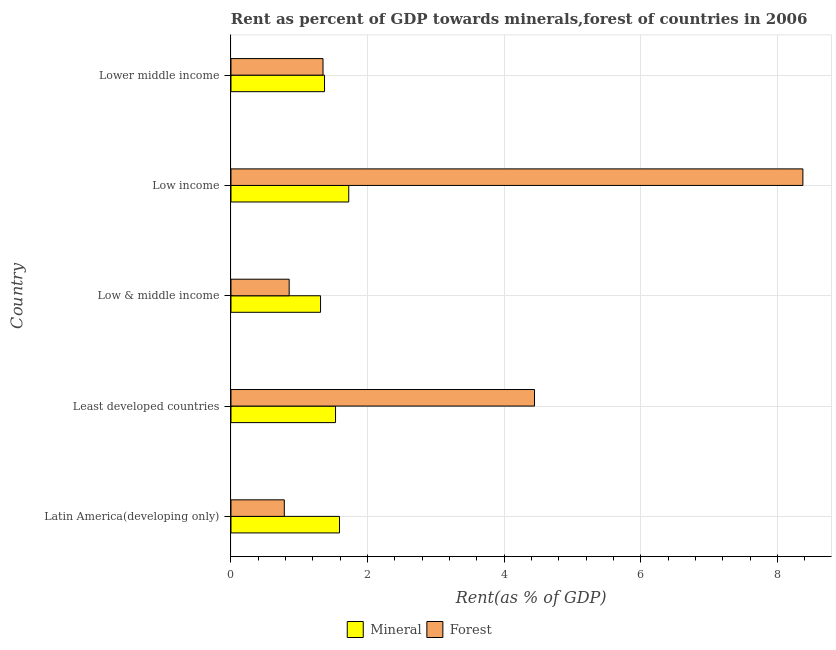Are the number of bars per tick equal to the number of legend labels?
Give a very brief answer. Yes. How many bars are there on the 5th tick from the top?
Offer a terse response. 2. What is the label of the 3rd group of bars from the top?
Give a very brief answer. Low & middle income. What is the mineral rent in Low & middle income?
Your response must be concise. 1.31. Across all countries, what is the maximum forest rent?
Make the answer very short. 8.37. Across all countries, what is the minimum mineral rent?
Your answer should be very brief. 1.31. What is the total forest rent in the graph?
Your answer should be compact. 15.8. What is the difference between the mineral rent in Low income and that in Lower middle income?
Your answer should be compact. 0.35. What is the difference between the mineral rent in Latin America(developing only) and the forest rent in Low income?
Ensure brevity in your answer.  -6.78. What is the average mineral rent per country?
Keep it short and to the point. 1.5. What is the difference between the forest rent and mineral rent in Lower middle income?
Make the answer very short. -0.02. What is the ratio of the mineral rent in Least developed countries to that in Low & middle income?
Give a very brief answer. 1.17. What is the difference between the highest and the second highest mineral rent?
Keep it short and to the point. 0.14. What is the difference between the highest and the lowest mineral rent?
Your answer should be very brief. 0.41. What does the 1st bar from the top in Least developed countries represents?
Provide a succinct answer. Forest. What does the 2nd bar from the bottom in Low income represents?
Your answer should be compact. Forest. How many bars are there?
Make the answer very short. 10. Does the graph contain any zero values?
Give a very brief answer. No. How many legend labels are there?
Offer a terse response. 2. What is the title of the graph?
Provide a short and direct response. Rent as percent of GDP towards minerals,forest of countries in 2006. Does "2012 US$" appear as one of the legend labels in the graph?
Make the answer very short. No. What is the label or title of the X-axis?
Offer a terse response. Rent(as % of GDP). What is the label or title of the Y-axis?
Provide a short and direct response. Country. What is the Rent(as % of GDP) of Mineral in Latin America(developing only)?
Keep it short and to the point. 1.59. What is the Rent(as % of GDP) of Forest in Latin America(developing only)?
Make the answer very short. 0.78. What is the Rent(as % of GDP) in Mineral in Least developed countries?
Your answer should be compact. 1.53. What is the Rent(as % of GDP) in Forest in Least developed countries?
Offer a very short reply. 4.44. What is the Rent(as % of GDP) of Mineral in Low & middle income?
Your answer should be compact. 1.31. What is the Rent(as % of GDP) in Forest in Low & middle income?
Offer a very short reply. 0.85. What is the Rent(as % of GDP) in Mineral in Low income?
Give a very brief answer. 1.72. What is the Rent(as % of GDP) in Forest in Low income?
Offer a terse response. 8.37. What is the Rent(as % of GDP) of Mineral in Lower middle income?
Your response must be concise. 1.37. What is the Rent(as % of GDP) in Forest in Lower middle income?
Your answer should be very brief. 1.35. Across all countries, what is the maximum Rent(as % of GDP) of Mineral?
Your response must be concise. 1.72. Across all countries, what is the maximum Rent(as % of GDP) in Forest?
Provide a short and direct response. 8.37. Across all countries, what is the minimum Rent(as % of GDP) in Mineral?
Your answer should be very brief. 1.31. Across all countries, what is the minimum Rent(as % of GDP) in Forest?
Your answer should be very brief. 0.78. What is the total Rent(as % of GDP) of Mineral in the graph?
Make the answer very short. 7.53. What is the total Rent(as % of GDP) of Forest in the graph?
Provide a short and direct response. 15.8. What is the difference between the Rent(as % of GDP) in Mineral in Latin America(developing only) and that in Least developed countries?
Keep it short and to the point. 0.06. What is the difference between the Rent(as % of GDP) in Forest in Latin America(developing only) and that in Least developed countries?
Offer a terse response. -3.66. What is the difference between the Rent(as % of GDP) in Mineral in Latin America(developing only) and that in Low & middle income?
Offer a terse response. 0.28. What is the difference between the Rent(as % of GDP) in Forest in Latin America(developing only) and that in Low & middle income?
Your answer should be compact. -0.07. What is the difference between the Rent(as % of GDP) in Mineral in Latin America(developing only) and that in Low income?
Ensure brevity in your answer.  -0.14. What is the difference between the Rent(as % of GDP) of Forest in Latin America(developing only) and that in Low income?
Ensure brevity in your answer.  -7.59. What is the difference between the Rent(as % of GDP) in Mineral in Latin America(developing only) and that in Lower middle income?
Your answer should be compact. 0.22. What is the difference between the Rent(as % of GDP) of Forest in Latin America(developing only) and that in Lower middle income?
Provide a short and direct response. -0.57. What is the difference between the Rent(as % of GDP) of Mineral in Least developed countries and that in Low & middle income?
Give a very brief answer. 0.22. What is the difference between the Rent(as % of GDP) in Forest in Least developed countries and that in Low & middle income?
Offer a terse response. 3.59. What is the difference between the Rent(as % of GDP) in Mineral in Least developed countries and that in Low income?
Your answer should be very brief. -0.19. What is the difference between the Rent(as % of GDP) in Forest in Least developed countries and that in Low income?
Your answer should be compact. -3.93. What is the difference between the Rent(as % of GDP) of Mineral in Least developed countries and that in Lower middle income?
Ensure brevity in your answer.  0.16. What is the difference between the Rent(as % of GDP) in Forest in Least developed countries and that in Lower middle income?
Ensure brevity in your answer.  3.1. What is the difference between the Rent(as % of GDP) in Mineral in Low & middle income and that in Low income?
Your answer should be compact. -0.41. What is the difference between the Rent(as % of GDP) in Forest in Low & middle income and that in Low income?
Your answer should be compact. -7.52. What is the difference between the Rent(as % of GDP) of Mineral in Low & middle income and that in Lower middle income?
Give a very brief answer. -0.06. What is the difference between the Rent(as % of GDP) of Forest in Low & middle income and that in Lower middle income?
Offer a terse response. -0.5. What is the difference between the Rent(as % of GDP) of Mineral in Low income and that in Lower middle income?
Offer a terse response. 0.35. What is the difference between the Rent(as % of GDP) in Forest in Low income and that in Lower middle income?
Offer a terse response. 7.03. What is the difference between the Rent(as % of GDP) in Mineral in Latin America(developing only) and the Rent(as % of GDP) in Forest in Least developed countries?
Provide a succinct answer. -2.86. What is the difference between the Rent(as % of GDP) in Mineral in Latin America(developing only) and the Rent(as % of GDP) in Forest in Low & middle income?
Provide a short and direct response. 0.74. What is the difference between the Rent(as % of GDP) in Mineral in Latin America(developing only) and the Rent(as % of GDP) in Forest in Low income?
Your answer should be compact. -6.78. What is the difference between the Rent(as % of GDP) in Mineral in Latin America(developing only) and the Rent(as % of GDP) in Forest in Lower middle income?
Your response must be concise. 0.24. What is the difference between the Rent(as % of GDP) of Mineral in Least developed countries and the Rent(as % of GDP) of Forest in Low & middle income?
Provide a succinct answer. 0.68. What is the difference between the Rent(as % of GDP) of Mineral in Least developed countries and the Rent(as % of GDP) of Forest in Low income?
Offer a very short reply. -6.84. What is the difference between the Rent(as % of GDP) of Mineral in Least developed countries and the Rent(as % of GDP) of Forest in Lower middle income?
Give a very brief answer. 0.18. What is the difference between the Rent(as % of GDP) of Mineral in Low & middle income and the Rent(as % of GDP) of Forest in Low income?
Provide a short and direct response. -7.06. What is the difference between the Rent(as % of GDP) in Mineral in Low & middle income and the Rent(as % of GDP) in Forest in Lower middle income?
Offer a very short reply. -0.04. What is the difference between the Rent(as % of GDP) of Mineral in Low income and the Rent(as % of GDP) of Forest in Lower middle income?
Offer a terse response. 0.38. What is the average Rent(as % of GDP) in Mineral per country?
Offer a terse response. 1.51. What is the average Rent(as % of GDP) of Forest per country?
Offer a very short reply. 3.16. What is the difference between the Rent(as % of GDP) of Mineral and Rent(as % of GDP) of Forest in Latin America(developing only)?
Provide a succinct answer. 0.81. What is the difference between the Rent(as % of GDP) in Mineral and Rent(as % of GDP) in Forest in Least developed countries?
Your answer should be compact. -2.91. What is the difference between the Rent(as % of GDP) in Mineral and Rent(as % of GDP) in Forest in Low & middle income?
Provide a short and direct response. 0.46. What is the difference between the Rent(as % of GDP) of Mineral and Rent(as % of GDP) of Forest in Low income?
Ensure brevity in your answer.  -6.65. What is the difference between the Rent(as % of GDP) of Mineral and Rent(as % of GDP) of Forest in Lower middle income?
Ensure brevity in your answer.  0.02. What is the ratio of the Rent(as % of GDP) in Mineral in Latin America(developing only) to that in Least developed countries?
Provide a succinct answer. 1.04. What is the ratio of the Rent(as % of GDP) in Forest in Latin America(developing only) to that in Least developed countries?
Ensure brevity in your answer.  0.18. What is the ratio of the Rent(as % of GDP) of Mineral in Latin America(developing only) to that in Low & middle income?
Ensure brevity in your answer.  1.21. What is the ratio of the Rent(as % of GDP) of Forest in Latin America(developing only) to that in Low & middle income?
Ensure brevity in your answer.  0.92. What is the ratio of the Rent(as % of GDP) in Mineral in Latin America(developing only) to that in Low income?
Keep it short and to the point. 0.92. What is the ratio of the Rent(as % of GDP) in Forest in Latin America(developing only) to that in Low income?
Your answer should be compact. 0.09. What is the ratio of the Rent(as % of GDP) in Mineral in Latin America(developing only) to that in Lower middle income?
Your response must be concise. 1.16. What is the ratio of the Rent(as % of GDP) of Forest in Latin America(developing only) to that in Lower middle income?
Give a very brief answer. 0.58. What is the ratio of the Rent(as % of GDP) of Mineral in Least developed countries to that in Low & middle income?
Keep it short and to the point. 1.17. What is the ratio of the Rent(as % of GDP) of Forest in Least developed countries to that in Low & middle income?
Keep it short and to the point. 5.22. What is the ratio of the Rent(as % of GDP) of Mineral in Least developed countries to that in Low income?
Your answer should be very brief. 0.89. What is the ratio of the Rent(as % of GDP) in Forest in Least developed countries to that in Low income?
Make the answer very short. 0.53. What is the ratio of the Rent(as % of GDP) in Mineral in Least developed countries to that in Lower middle income?
Offer a terse response. 1.12. What is the ratio of the Rent(as % of GDP) in Forest in Least developed countries to that in Lower middle income?
Offer a terse response. 3.3. What is the ratio of the Rent(as % of GDP) in Mineral in Low & middle income to that in Low income?
Keep it short and to the point. 0.76. What is the ratio of the Rent(as % of GDP) in Forest in Low & middle income to that in Low income?
Give a very brief answer. 0.1. What is the ratio of the Rent(as % of GDP) in Mineral in Low & middle income to that in Lower middle income?
Provide a succinct answer. 0.96. What is the ratio of the Rent(as % of GDP) of Forest in Low & middle income to that in Lower middle income?
Make the answer very short. 0.63. What is the ratio of the Rent(as % of GDP) in Mineral in Low income to that in Lower middle income?
Your answer should be very brief. 1.26. What is the ratio of the Rent(as % of GDP) of Forest in Low income to that in Lower middle income?
Make the answer very short. 6.21. What is the difference between the highest and the second highest Rent(as % of GDP) of Mineral?
Provide a short and direct response. 0.14. What is the difference between the highest and the second highest Rent(as % of GDP) of Forest?
Your response must be concise. 3.93. What is the difference between the highest and the lowest Rent(as % of GDP) in Mineral?
Your answer should be very brief. 0.41. What is the difference between the highest and the lowest Rent(as % of GDP) in Forest?
Your response must be concise. 7.59. 